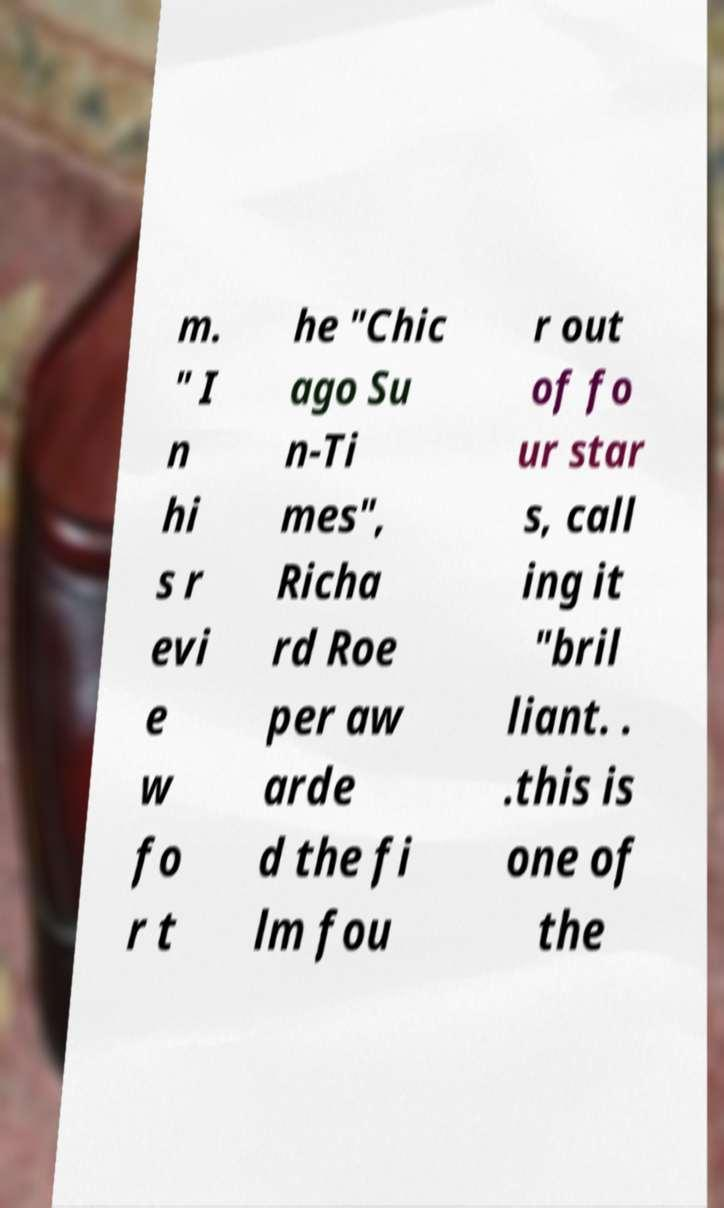Can you read and provide the text displayed in the image?This photo seems to have some interesting text. Can you extract and type it out for me? m. " I n hi s r evi e w fo r t he "Chic ago Su n-Ti mes", Richa rd Roe per aw arde d the fi lm fou r out of fo ur star s, call ing it "bril liant. . .this is one of the 